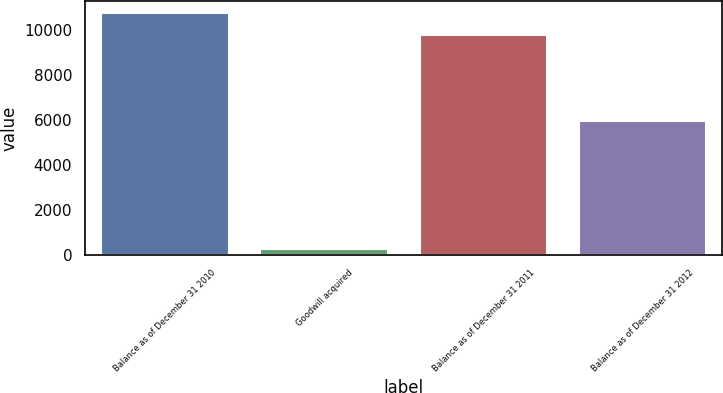<chart> <loc_0><loc_0><loc_500><loc_500><bar_chart><fcel>Balance as of December 31 2010<fcel>Goodwill acquired<fcel>Balance as of December 31 2011<fcel>Balance as of December 31 2012<nl><fcel>10753<fcel>266<fcel>9761<fcel>5973<nl></chart> 